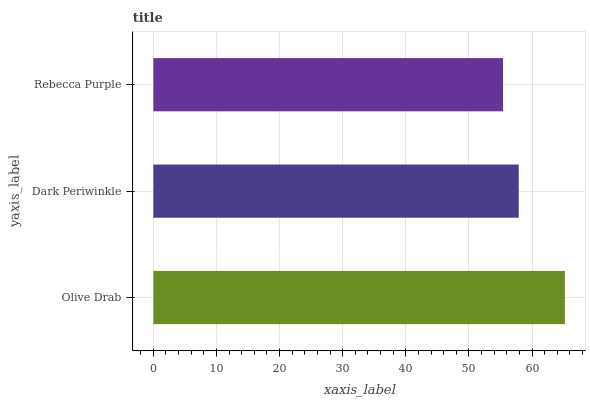Is Rebecca Purple the minimum?
Answer yes or no. Yes. Is Olive Drab the maximum?
Answer yes or no. Yes. Is Dark Periwinkle the minimum?
Answer yes or no. No. Is Dark Periwinkle the maximum?
Answer yes or no. No. Is Olive Drab greater than Dark Periwinkle?
Answer yes or no. Yes. Is Dark Periwinkle less than Olive Drab?
Answer yes or no. Yes. Is Dark Periwinkle greater than Olive Drab?
Answer yes or no. No. Is Olive Drab less than Dark Periwinkle?
Answer yes or no. No. Is Dark Periwinkle the high median?
Answer yes or no. Yes. Is Dark Periwinkle the low median?
Answer yes or no. Yes. Is Rebecca Purple the high median?
Answer yes or no. No. Is Olive Drab the low median?
Answer yes or no. No. 